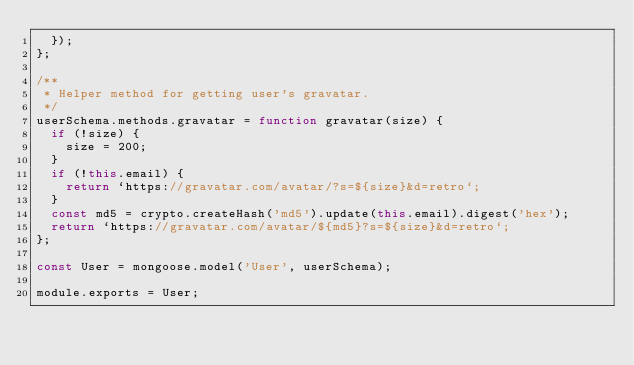Convert code to text. <code><loc_0><loc_0><loc_500><loc_500><_JavaScript_>  });
};

/**
 * Helper method for getting user's gravatar.
 */
userSchema.methods.gravatar = function gravatar(size) {
  if (!size) {
    size = 200;
  }
  if (!this.email) {
    return `https://gravatar.com/avatar/?s=${size}&d=retro`;
  }
  const md5 = crypto.createHash('md5').update(this.email).digest('hex');
  return `https://gravatar.com/avatar/${md5}?s=${size}&d=retro`;
};

const User = mongoose.model('User', userSchema);

module.exports = User;
</code> 